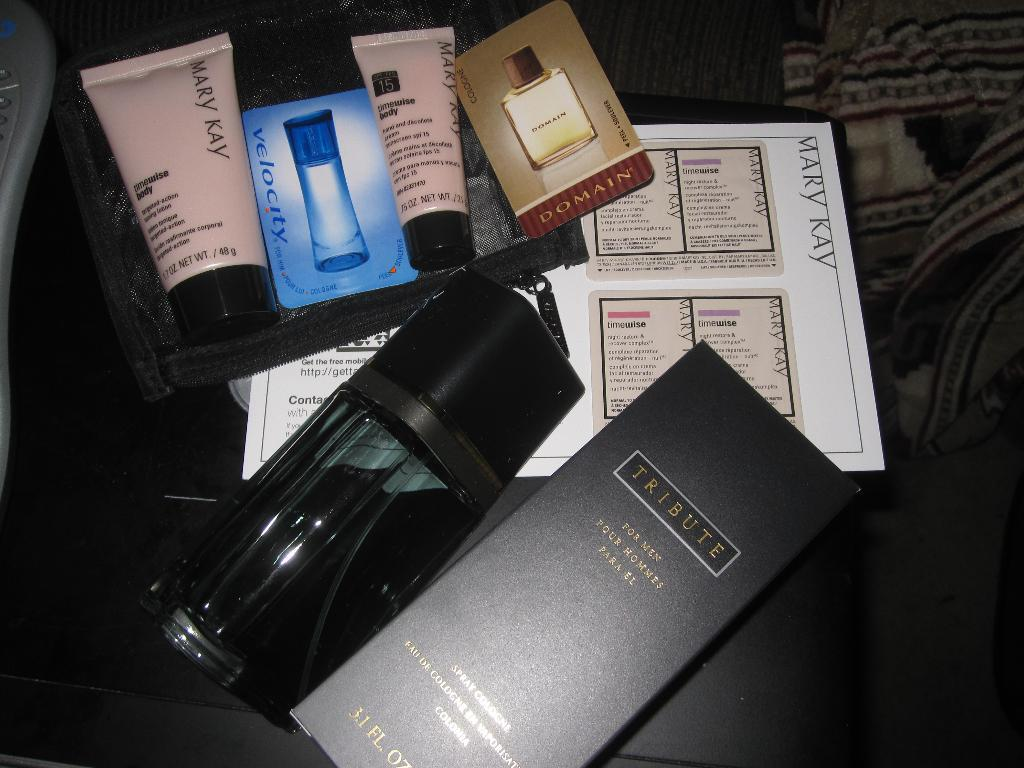<image>
Summarize the visual content of the image. Some cologne and Mary Kay products are out on a counter. 